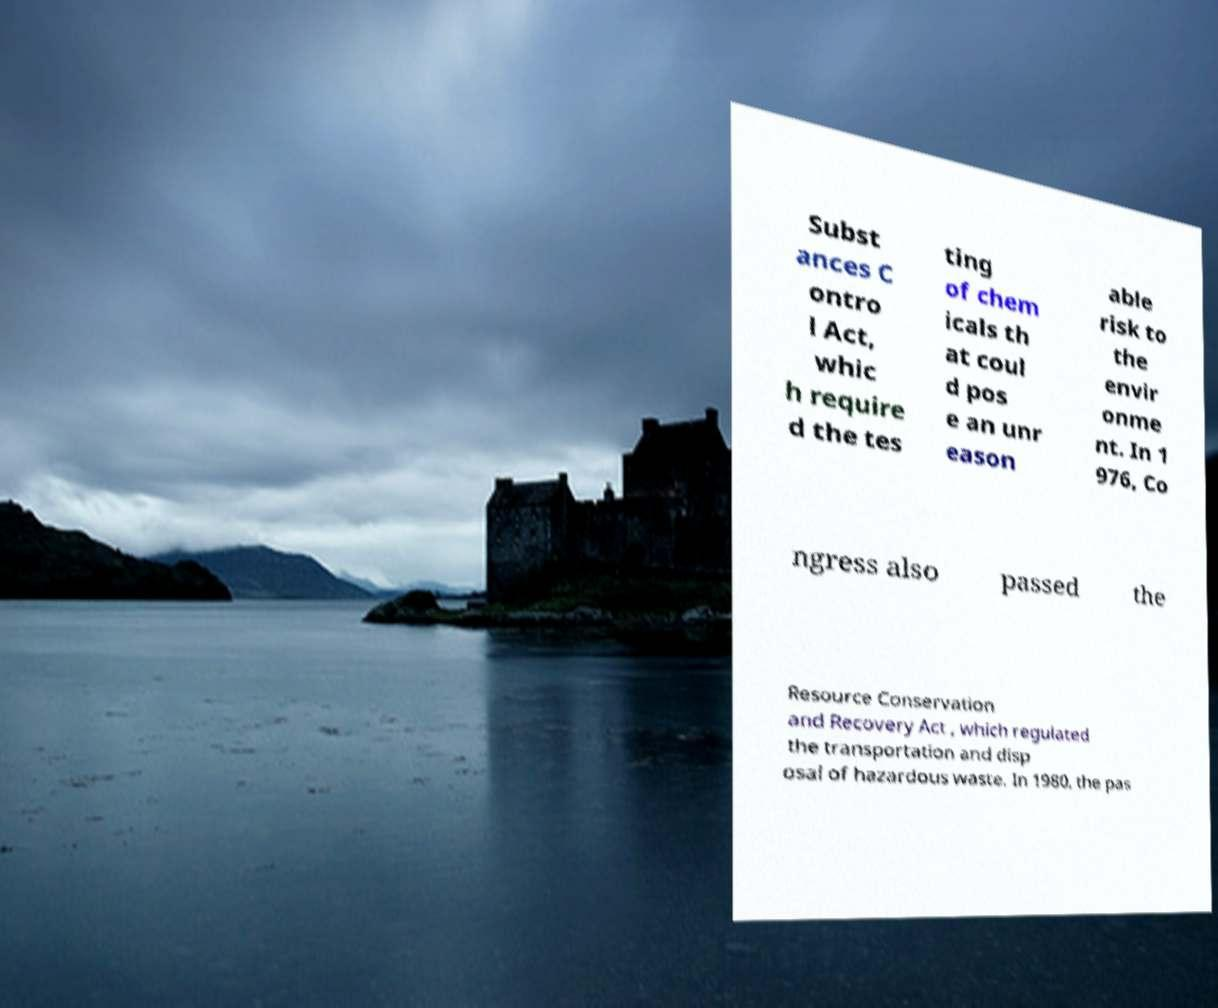I need the written content from this picture converted into text. Can you do that? Subst ances C ontro l Act, whic h require d the tes ting of chem icals th at coul d pos e an unr eason able risk to the envir onme nt. In 1 976, Co ngress also passed the Resource Conservation and Recovery Act , which regulated the transportation and disp osal of hazardous waste. In 1980, the pas 